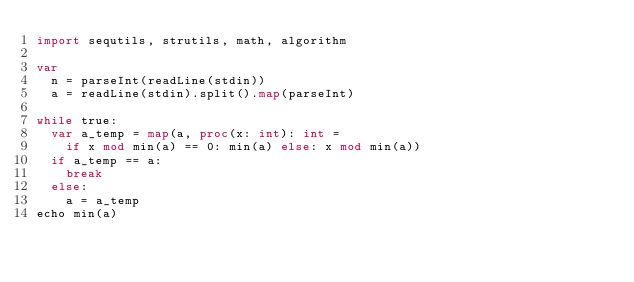<code> <loc_0><loc_0><loc_500><loc_500><_Nim_>import sequtils, strutils, math, algorithm

var
  n = parseInt(readLine(stdin))
  a = readLine(stdin).split().map(parseInt)

while true:
  var a_temp = map(a, proc(x: int): int =
    if x mod min(a) == 0: min(a) else: x mod min(a))
  if a_temp == a:
    break
  else:
    a = a_temp
echo min(a)</code> 